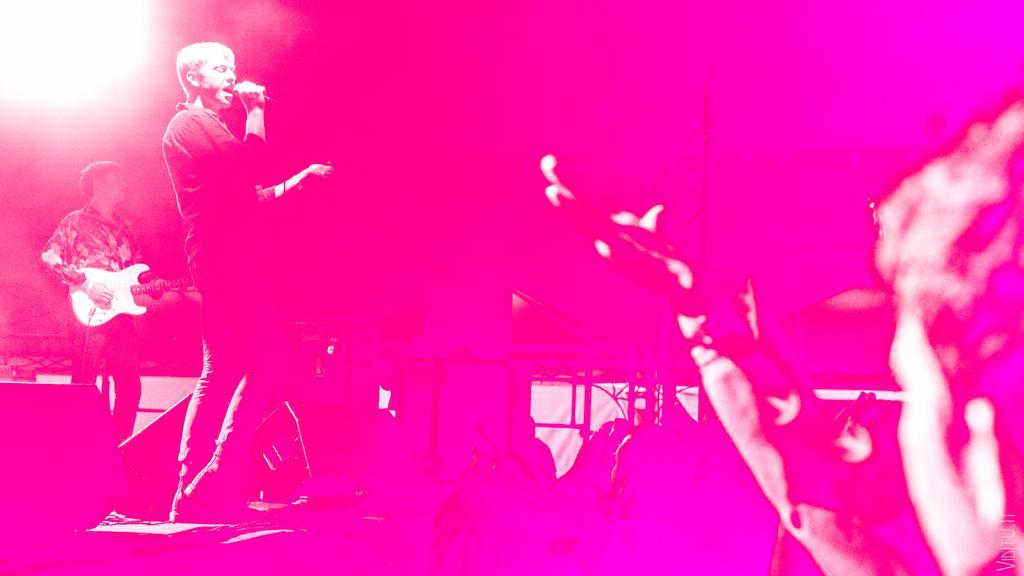Could you give a brief overview of what you see in this image? In this image, we can see few people. On the left side of the image, we can see a person is holding a microphone and singing. Here a person is holding a guitar and playing. 